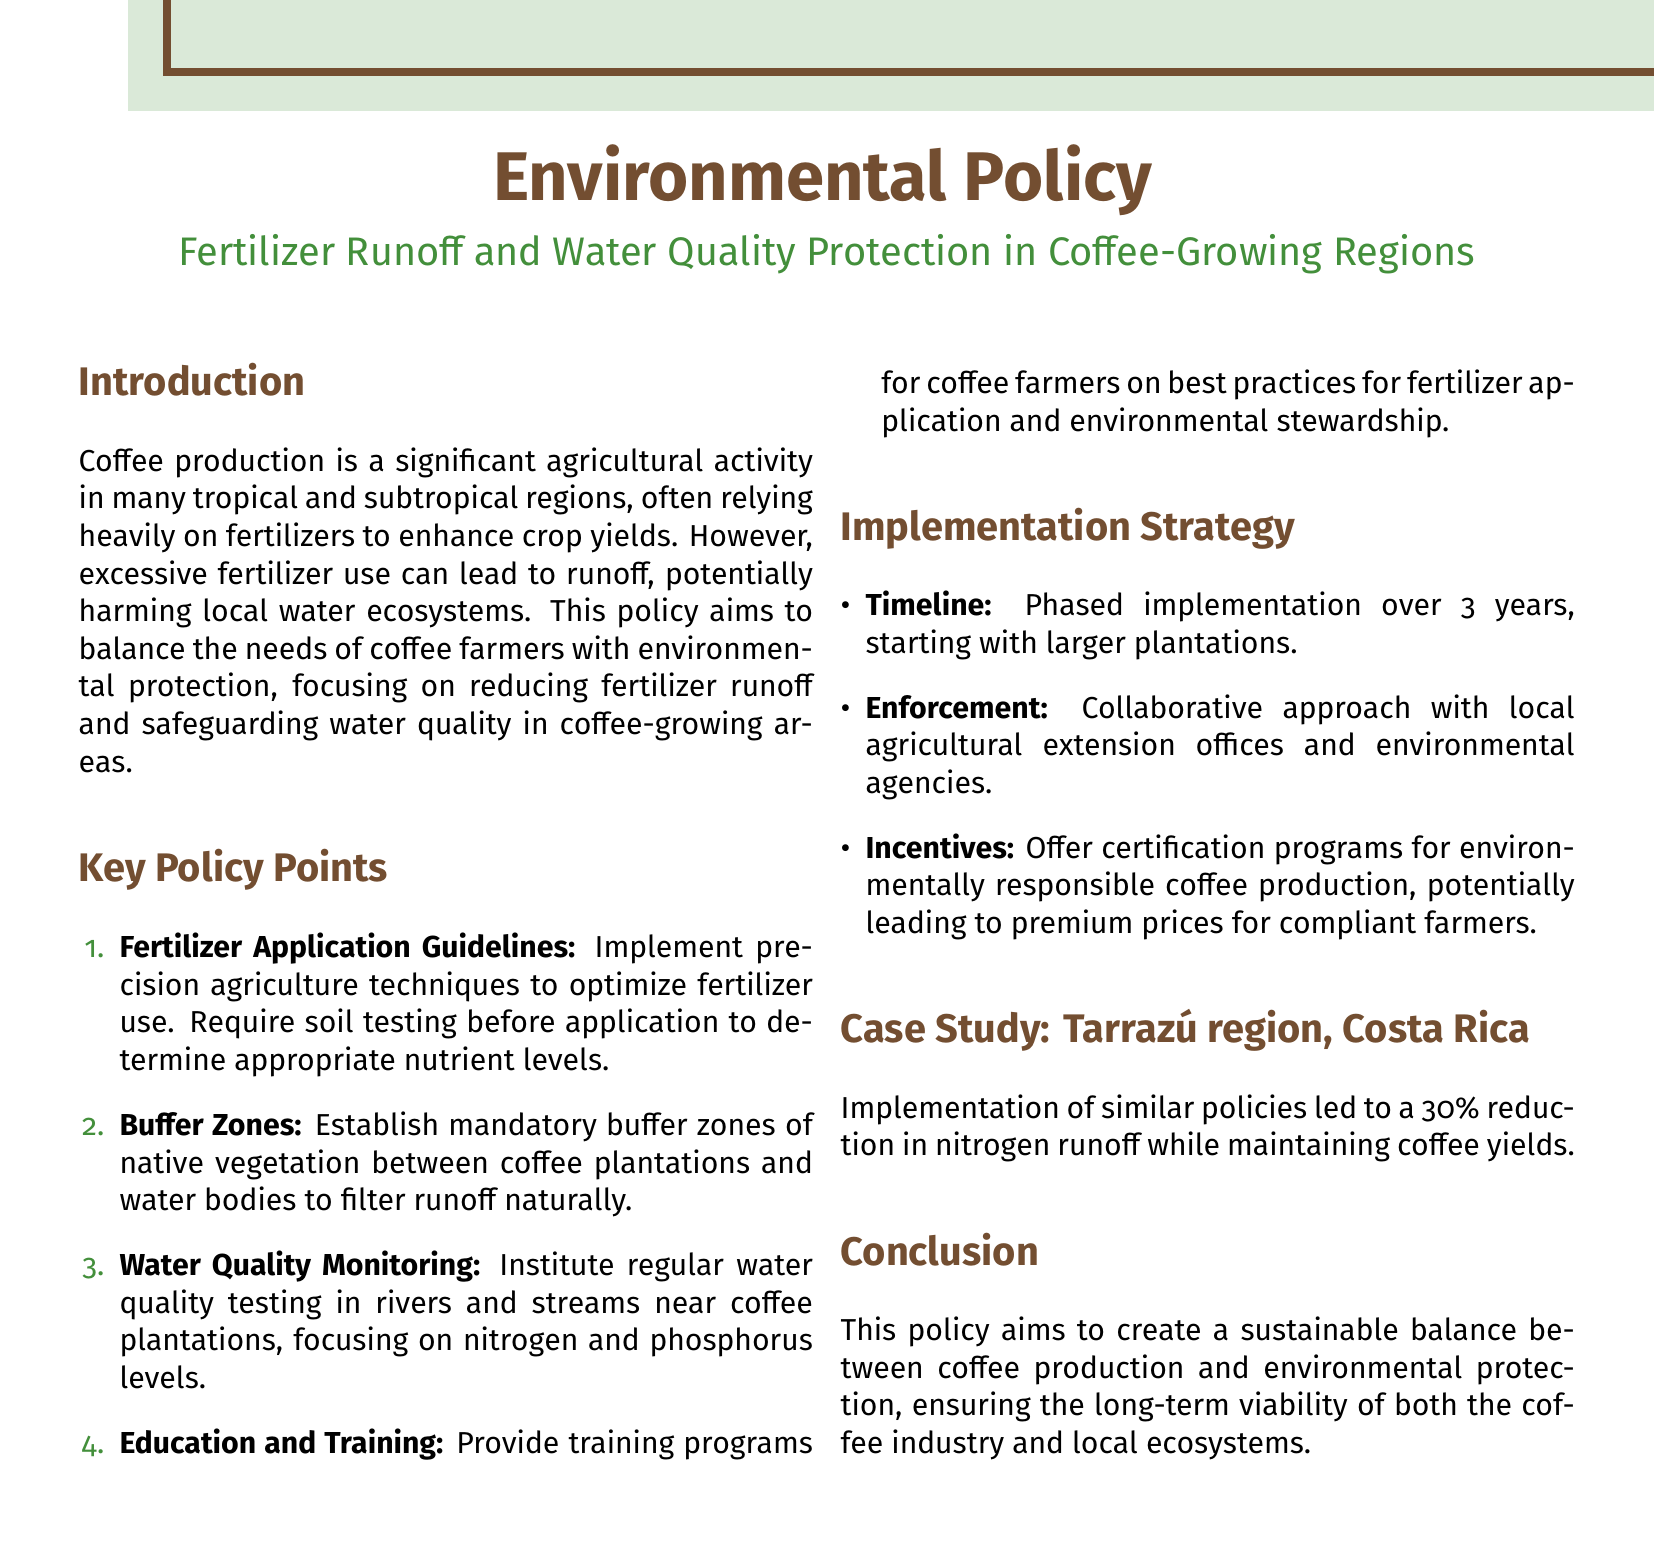What is the title of the policy document? The title of the policy document is clearly stated in the introduction section.
Answer: Environmental Policy What is the percentage reduction in nitrogen runoff achieved in the Tarrazú region? The document presents a case study referring to the effectiveness of similar policies in this region.
Answer: 30% What are the two main substances monitored in the water quality testing? The key points section mentions the focus on specific nutrients during monitoring.
Answer: Nitrogen and phosphorus What is required before fertilizer application according to the guidelines? The guidelines emphasize an essential step that should be taken before applying fertilizers.
Answer: Soil testing What is the timeline for the implementation of the policy? The implementation strategy section specifies how long the rollout of the policy will take.
Answer: 3 years What type of approach is suggested for enforcement? The document discusses a method for implementing the policy which involves collaboration.
Answer: Collaborative approach What is the main goal of this policy? The conclusion provided summarizes the primary aim of the policy concerning agriculture and the environment.
Answer: Sustainable balance 